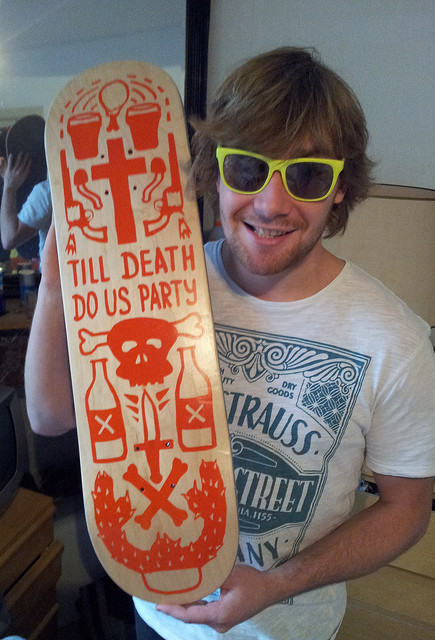Please extract the text content from this image. TILL DEATH DO US PARTy ANY IISS M TREET TRAUSS COODS DKYT m 